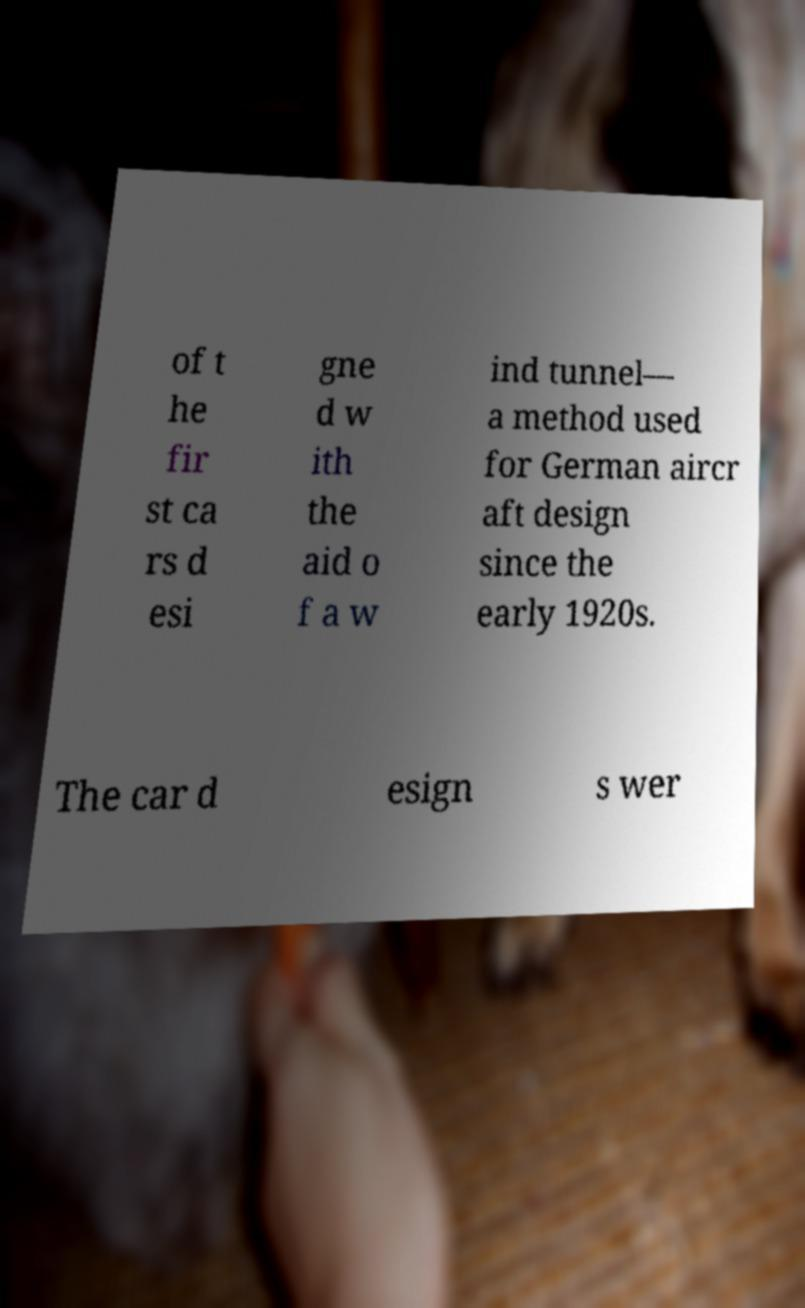I need the written content from this picture converted into text. Can you do that? of t he fir st ca rs d esi gne d w ith the aid o f a w ind tunnel— a method used for German aircr aft design since the early 1920s. The car d esign s wer 